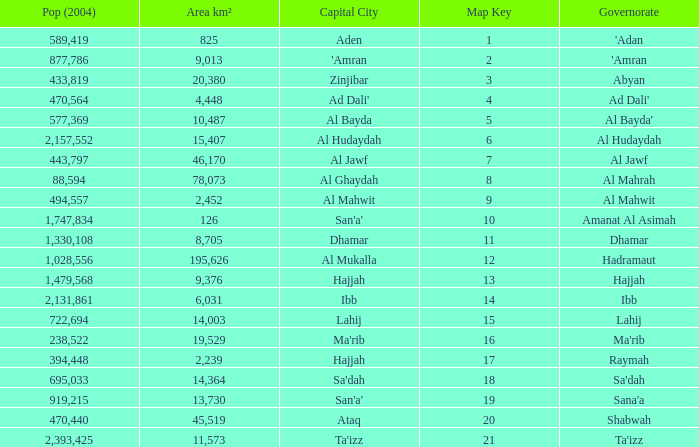Name the amount of Map Key which has a Pop (2004) smaller than 433,819, and a Capital City of hajjah, and an Area km² smaller than 9,376? Question 1 17.0. 